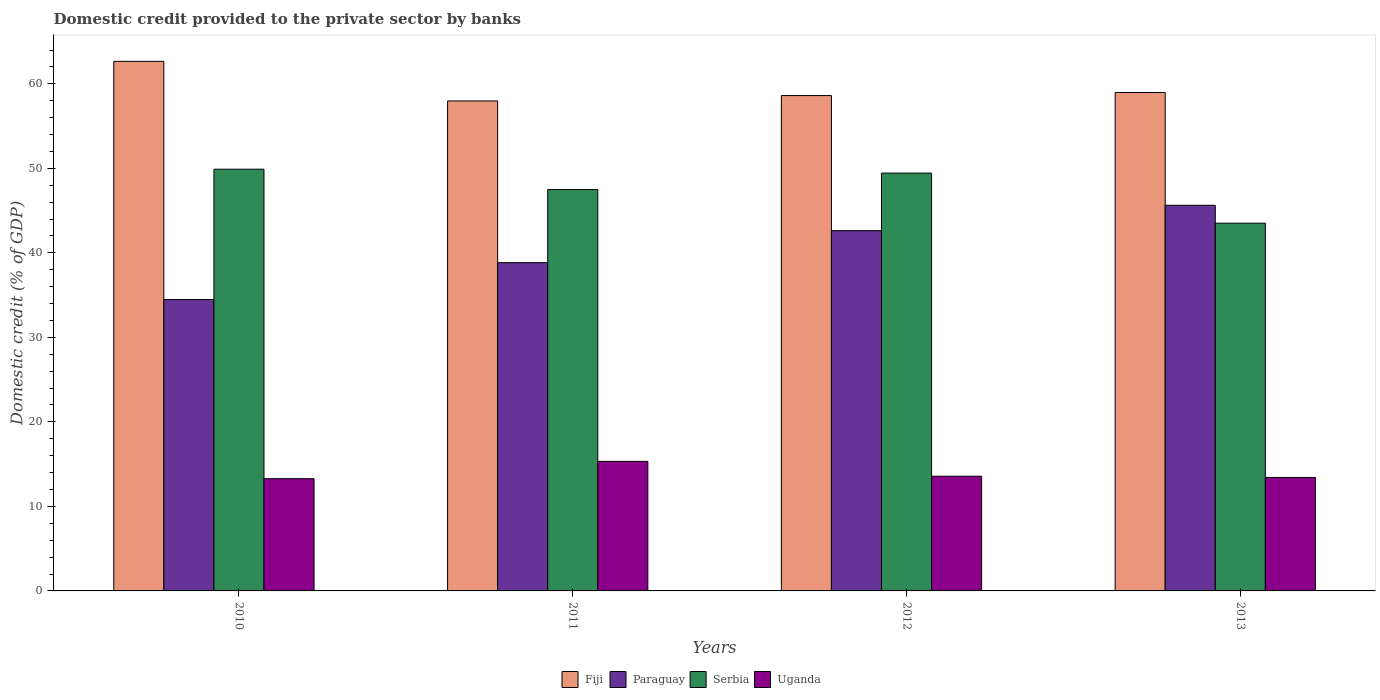How many groups of bars are there?
Your answer should be compact. 4. Are the number of bars per tick equal to the number of legend labels?
Ensure brevity in your answer.  Yes. Are the number of bars on each tick of the X-axis equal?
Give a very brief answer. Yes. How many bars are there on the 4th tick from the left?
Ensure brevity in your answer.  4. How many bars are there on the 2nd tick from the right?
Offer a terse response. 4. What is the domestic credit provided to the private sector by banks in Uganda in 2012?
Ensure brevity in your answer.  13.57. Across all years, what is the maximum domestic credit provided to the private sector by banks in Serbia?
Offer a very short reply. 49.9. Across all years, what is the minimum domestic credit provided to the private sector by banks in Fiji?
Give a very brief answer. 57.97. In which year was the domestic credit provided to the private sector by banks in Fiji maximum?
Keep it short and to the point. 2010. What is the total domestic credit provided to the private sector by banks in Uganda in the graph?
Provide a succinct answer. 55.61. What is the difference between the domestic credit provided to the private sector by banks in Uganda in 2010 and that in 2013?
Keep it short and to the point. -0.15. What is the difference between the domestic credit provided to the private sector by banks in Fiji in 2012 and the domestic credit provided to the private sector by banks in Paraguay in 2013?
Your answer should be very brief. 12.98. What is the average domestic credit provided to the private sector by banks in Fiji per year?
Offer a very short reply. 59.55. In the year 2013, what is the difference between the domestic credit provided to the private sector by banks in Serbia and domestic credit provided to the private sector by banks in Uganda?
Keep it short and to the point. 30.08. What is the ratio of the domestic credit provided to the private sector by banks in Uganda in 2012 to that in 2013?
Your answer should be compact. 1.01. Is the domestic credit provided to the private sector by banks in Paraguay in 2011 less than that in 2013?
Offer a very short reply. Yes. What is the difference between the highest and the second highest domestic credit provided to the private sector by banks in Uganda?
Give a very brief answer. 1.75. What is the difference between the highest and the lowest domestic credit provided to the private sector by banks in Serbia?
Keep it short and to the point. 6.39. In how many years, is the domestic credit provided to the private sector by banks in Uganda greater than the average domestic credit provided to the private sector by banks in Uganda taken over all years?
Provide a succinct answer. 1. Is the sum of the domestic credit provided to the private sector by banks in Paraguay in 2010 and 2012 greater than the maximum domestic credit provided to the private sector by banks in Serbia across all years?
Give a very brief answer. Yes. What does the 1st bar from the left in 2010 represents?
Make the answer very short. Fiji. What does the 1st bar from the right in 2013 represents?
Provide a succinct answer. Uganda. Is it the case that in every year, the sum of the domestic credit provided to the private sector by banks in Fiji and domestic credit provided to the private sector by banks in Serbia is greater than the domestic credit provided to the private sector by banks in Uganda?
Your answer should be compact. Yes. How many years are there in the graph?
Offer a very short reply. 4. Are the values on the major ticks of Y-axis written in scientific E-notation?
Offer a very short reply. No. Does the graph contain any zero values?
Offer a very short reply. No. Does the graph contain grids?
Provide a short and direct response. No. Where does the legend appear in the graph?
Keep it short and to the point. Bottom center. How many legend labels are there?
Your answer should be very brief. 4. What is the title of the graph?
Keep it short and to the point. Domestic credit provided to the private sector by banks. What is the label or title of the Y-axis?
Your response must be concise. Domestic credit (% of GDP). What is the Domestic credit (% of GDP) of Fiji in 2010?
Provide a succinct answer. 62.66. What is the Domestic credit (% of GDP) of Paraguay in 2010?
Give a very brief answer. 34.48. What is the Domestic credit (% of GDP) of Serbia in 2010?
Give a very brief answer. 49.9. What is the Domestic credit (% of GDP) in Uganda in 2010?
Provide a short and direct response. 13.28. What is the Domestic credit (% of GDP) of Fiji in 2011?
Provide a succinct answer. 57.97. What is the Domestic credit (% of GDP) in Paraguay in 2011?
Offer a terse response. 38.84. What is the Domestic credit (% of GDP) of Serbia in 2011?
Your response must be concise. 47.49. What is the Domestic credit (% of GDP) in Uganda in 2011?
Keep it short and to the point. 15.33. What is the Domestic credit (% of GDP) in Fiji in 2012?
Your answer should be compact. 58.61. What is the Domestic credit (% of GDP) of Paraguay in 2012?
Offer a very short reply. 42.62. What is the Domestic credit (% of GDP) in Serbia in 2012?
Offer a terse response. 49.44. What is the Domestic credit (% of GDP) in Uganda in 2012?
Make the answer very short. 13.57. What is the Domestic credit (% of GDP) in Fiji in 2013?
Offer a very short reply. 58.97. What is the Domestic credit (% of GDP) of Paraguay in 2013?
Ensure brevity in your answer.  45.63. What is the Domestic credit (% of GDP) of Serbia in 2013?
Provide a succinct answer. 43.51. What is the Domestic credit (% of GDP) of Uganda in 2013?
Give a very brief answer. 13.43. Across all years, what is the maximum Domestic credit (% of GDP) in Fiji?
Your response must be concise. 62.66. Across all years, what is the maximum Domestic credit (% of GDP) in Paraguay?
Make the answer very short. 45.63. Across all years, what is the maximum Domestic credit (% of GDP) of Serbia?
Give a very brief answer. 49.9. Across all years, what is the maximum Domestic credit (% of GDP) of Uganda?
Provide a short and direct response. 15.33. Across all years, what is the minimum Domestic credit (% of GDP) in Fiji?
Make the answer very short. 57.97. Across all years, what is the minimum Domestic credit (% of GDP) in Paraguay?
Your response must be concise. 34.48. Across all years, what is the minimum Domestic credit (% of GDP) of Serbia?
Ensure brevity in your answer.  43.51. Across all years, what is the minimum Domestic credit (% of GDP) of Uganda?
Your answer should be compact. 13.28. What is the total Domestic credit (% of GDP) in Fiji in the graph?
Make the answer very short. 238.22. What is the total Domestic credit (% of GDP) of Paraguay in the graph?
Your answer should be compact. 161.57. What is the total Domestic credit (% of GDP) in Serbia in the graph?
Ensure brevity in your answer.  190.33. What is the total Domestic credit (% of GDP) of Uganda in the graph?
Your answer should be very brief. 55.61. What is the difference between the Domestic credit (% of GDP) in Fiji in 2010 and that in 2011?
Provide a succinct answer. 4.68. What is the difference between the Domestic credit (% of GDP) of Paraguay in 2010 and that in 2011?
Keep it short and to the point. -4.36. What is the difference between the Domestic credit (% of GDP) of Serbia in 2010 and that in 2011?
Keep it short and to the point. 2.41. What is the difference between the Domestic credit (% of GDP) in Uganda in 2010 and that in 2011?
Provide a short and direct response. -2.05. What is the difference between the Domestic credit (% of GDP) of Fiji in 2010 and that in 2012?
Your response must be concise. 4.05. What is the difference between the Domestic credit (% of GDP) in Paraguay in 2010 and that in 2012?
Make the answer very short. -8.14. What is the difference between the Domestic credit (% of GDP) of Serbia in 2010 and that in 2012?
Make the answer very short. 0.46. What is the difference between the Domestic credit (% of GDP) in Uganda in 2010 and that in 2012?
Your response must be concise. -0.29. What is the difference between the Domestic credit (% of GDP) in Fiji in 2010 and that in 2013?
Keep it short and to the point. 3.68. What is the difference between the Domestic credit (% of GDP) in Paraguay in 2010 and that in 2013?
Ensure brevity in your answer.  -11.15. What is the difference between the Domestic credit (% of GDP) of Serbia in 2010 and that in 2013?
Keep it short and to the point. 6.39. What is the difference between the Domestic credit (% of GDP) of Uganda in 2010 and that in 2013?
Your answer should be compact. -0.15. What is the difference between the Domestic credit (% of GDP) in Fiji in 2011 and that in 2012?
Your response must be concise. -0.64. What is the difference between the Domestic credit (% of GDP) of Paraguay in 2011 and that in 2012?
Make the answer very short. -3.79. What is the difference between the Domestic credit (% of GDP) of Serbia in 2011 and that in 2012?
Offer a very short reply. -1.95. What is the difference between the Domestic credit (% of GDP) of Uganda in 2011 and that in 2012?
Your answer should be very brief. 1.75. What is the difference between the Domestic credit (% of GDP) in Fiji in 2011 and that in 2013?
Offer a terse response. -1. What is the difference between the Domestic credit (% of GDP) of Paraguay in 2011 and that in 2013?
Offer a very short reply. -6.79. What is the difference between the Domestic credit (% of GDP) in Serbia in 2011 and that in 2013?
Make the answer very short. 3.98. What is the difference between the Domestic credit (% of GDP) of Uganda in 2011 and that in 2013?
Your answer should be very brief. 1.9. What is the difference between the Domestic credit (% of GDP) in Fiji in 2012 and that in 2013?
Keep it short and to the point. -0.36. What is the difference between the Domestic credit (% of GDP) in Paraguay in 2012 and that in 2013?
Make the answer very short. -3.01. What is the difference between the Domestic credit (% of GDP) of Serbia in 2012 and that in 2013?
Provide a short and direct response. 5.92. What is the difference between the Domestic credit (% of GDP) in Uganda in 2012 and that in 2013?
Make the answer very short. 0.15. What is the difference between the Domestic credit (% of GDP) of Fiji in 2010 and the Domestic credit (% of GDP) of Paraguay in 2011?
Your answer should be very brief. 23.82. What is the difference between the Domestic credit (% of GDP) in Fiji in 2010 and the Domestic credit (% of GDP) in Serbia in 2011?
Make the answer very short. 15.17. What is the difference between the Domestic credit (% of GDP) of Fiji in 2010 and the Domestic credit (% of GDP) of Uganda in 2011?
Make the answer very short. 47.33. What is the difference between the Domestic credit (% of GDP) of Paraguay in 2010 and the Domestic credit (% of GDP) of Serbia in 2011?
Ensure brevity in your answer.  -13.01. What is the difference between the Domestic credit (% of GDP) in Paraguay in 2010 and the Domestic credit (% of GDP) in Uganda in 2011?
Ensure brevity in your answer.  19.15. What is the difference between the Domestic credit (% of GDP) in Serbia in 2010 and the Domestic credit (% of GDP) in Uganda in 2011?
Provide a short and direct response. 34.57. What is the difference between the Domestic credit (% of GDP) of Fiji in 2010 and the Domestic credit (% of GDP) of Paraguay in 2012?
Ensure brevity in your answer.  20.03. What is the difference between the Domestic credit (% of GDP) in Fiji in 2010 and the Domestic credit (% of GDP) in Serbia in 2012?
Your answer should be compact. 13.22. What is the difference between the Domestic credit (% of GDP) of Fiji in 2010 and the Domestic credit (% of GDP) of Uganda in 2012?
Offer a terse response. 49.09. What is the difference between the Domestic credit (% of GDP) in Paraguay in 2010 and the Domestic credit (% of GDP) in Serbia in 2012?
Provide a succinct answer. -14.96. What is the difference between the Domestic credit (% of GDP) in Paraguay in 2010 and the Domestic credit (% of GDP) in Uganda in 2012?
Ensure brevity in your answer.  20.91. What is the difference between the Domestic credit (% of GDP) of Serbia in 2010 and the Domestic credit (% of GDP) of Uganda in 2012?
Offer a terse response. 36.32. What is the difference between the Domestic credit (% of GDP) of Fiji in 2010 and the Domestic credit (% of GDP) of Paraguay in 2013?
Provide a succinct answer. 17.03. What is the difference between the Domestic credit (% of GDP) of Fiji in 2010 and the Domestic credit (% of GDP) of Serbia in 2013?
Offer a very short reply. 19.15. What is the difference between the Domestic credit (% of GDP) in Fiji in 2010 and the Domestic credit (% of GDP) in Uganda in 2013?
Provide a short and direct response. 49.23. What is the difference between the Domestic credit (% of GDP) of Paraguay in 2010 and the Domestic credit (% of GDP) of Serbia in 2013?
Keep it short and to the point. -9.03. What is the difference between the Domestic credit (% of GDP) of Paraguay in 2010 and the Domestic credit (% of GDP) of Uganda in 2013?
Keep it short and to the point. 21.05. What is the difference between the Domestic credit (% of GDP) of Serbia in 2010 and the Domestic credit (% of GDP) of Uganda in 2013?
Ensure brevity in your answer.  36.47. What is the difference between the Domestic credit (% of GDP) of Fiji in 2011 and the Domestic credit (% of GDP) of Paraguay in 2012?
Your answer should be very brief. 15.35. What is the difference between the Domestic credit (% of GDP) in Fiji in 2011 and the Domestic credit (% of GDP) in Serbia in 2012?
Give a very brief answer. 8.54. What is the difference between the Domestic credit (% of GDP) of Fiji in 2011 and the Domestic credit (% of GDP) of Uganda in 2012?
Make the answer very short. 44.4. What is the difference between the Domestic credit (% of GDP) of Paraguay in 2011 and the Domestic credit (% of GDP) of Serbia in 2012?
Your answer should be very brief. -10.6. What is the difference between the Domestic credit (% of GDP) in Paraguay in 2011 and the Domestic credit (% of GDP) in Uganda in 2012?
Provide a short and direct response. 25.26. What is the difference between the Domestic credit (% of GDP) of Serbia in 2011 and the Domestic credit (% of GDP) of Uganda in 2012?
Ensure brevity in your answer.  33.92. What is the difference between the Domestic credit (% of GDP) of Fiji in 2011 and the Domestic credit (% of GDP) of Paraguay in 2013?
Provide a succinct answer. 12.34. What is the difference between the Domestic credit (% of GDP) of Fiji in 2011 and the Domestic credit (% of GDP) of Serbia in 2013?
Your answer should be very brief. 14.46. What is the difference between the Domestic credit (% of GDP) in Fiji in 2011 and the Domestic credit (% of GDP) in Uganda in 2013?
Give a very brief answer. 44.55. What is the difference between the Domestic credit (% of GDP) of Paraguay in 2011 and the Domestic credit (% of GDP) of Serbia in 2013?
Provide a succinct answer. -4.67. What is the difference between the Domestic credit (% of GDP) in Paraguay in 2011 and the Domestic credit (% of GDP) in Uganda in 2013?
Ensure brevity in your answer.  25.41. What is the difference between the Domestic credit (% of GDP) of Serbia in 2011 and the Domestic credit (% of GDP) of Uganda in 2013?
Make the answer very short. 34.06. What is the difference between the Domestic credit (% of GDP) of Fiji in 2012 and the Domestic credit (% of GDP) of Paraguay in 2013?
Offer a very short reply. 12.98. What is the difference between the Domestic credit (% of GDP) in Fiji in 2012 and the Domestic credit (% of GDP) in Serbia in 2013?
Give a very brief answer. 15.1. What is the difference between the Domestic credit (% of GDP) in Fiji in 2012 and the Domestic credit (% of GDP) in Uganda in 2013?
Give a very brief answer. 45.18. What is the difference between the Domestic credit (% of GDP) of Paraguay in 2012 and the Domestic credit (% of GDP) of Serbia in 2013?
Offer a very short reply. -0.89. What is the difference between the Domestic credit (% of GDP) in Paraguay in 2012 and the Domestic credit (% of GDP) in Uganda in 2013?
Your answer should be compact. 29.2. What is the difference between the Domestic credit (% of GDP) of Serbia in 2012 and the Domestic credit (% of GDP) of Uganda in 2013?
Your answer should be very brief. 36.01. What is the average Domestic credit (% of GDP) of Fiji per year?
Ensure brevity in your answer.  59.55. What is the average Domestic credit (% of GDP) in Paraguay per year?
Keep it short and to the point. 40.39. What is the average Domestic credit (% of GDP) in Serbia per year?
Make the answer very short. 47.58. What is the average Domestic credit (% of GDP) of Uganda per year?
Provide a succinct answer. 13.9. In the year 2010, what is the difference between the Domestic credit (% of GDP) of Fiji and Domestic credit (% of GDP) of Paraguay?
Your answer should be compact. 28.18. In the year 2010, what is the difference between the Domestic credit (% of GDP) in Fiji and Domestic credit (% of GDP) in Serbia?
Offer a very short reply. 12.76. In the year 2010, what is the difference between the Domestic credit (% of GDP) of Fiji and Domestic credit (% of GDP) of Uganda?
Provide a succinct answer. 49.38. In the year 2010, what is the difference between the Domestic credit (% of GDP) of Paraguay and Domestic credit (% of GDP) of Serbia?
Give a very brief answer. -15.42. In the year 2010, what is the difference between the Domestic credit (% of GDP) of Paraguay and Domestic credit (% of GDP) of Uganda?
Offer a very short reply. 21.2. In the year 2010, what is the difference between the Domestic credit (% of GDP) of Serbia and Domestic credit (% of GDP) of Uganda?
Your answer should be very brief. 36.62. In the year 2011, what is the difference between the Domestic credit (% of GDP) of Fiji and Domestic credit (% of GDP) of Paraguay?
Your answer should be very brief. 19.14. In the year 2011, what is the difference between the Domestic credit (% of GDP) in Fiji and Domestic credit (% of GDP) in Serbia?
Offer a terse response. 10.48. In the year 2011, what is the difference between the Domestic credit (% of GDP) in Fiji and Domestic credit (% of GDP) in Uganda?
Your answer should be very brief. 42.65. In the year 2011, what is the difference between the Domestic credit (% of GDP) of Paraguay and Domestic credit (% of GDP) of Serbia?
Offer a terse response. -8.65. In the year 2011, what is the difference between the Domestic credit (% of GDP) of Paraguay and Domestic credit (% of GDP) of Uganda?
Your answer should be very brief. 23.51. In the year 2011, what is the difference between the Domestic credit (% of GDP) of Serbia and Domestic credit (% of GDP) of Uganda?
Your response must be concise. 32.16. In the year 2012, what is the difference between the Domestic credit (% of GDP) of Fiji and Domestic credit (% of GDP) of Paraguay?
Provide a short and direct response. 15.99. In the year 2012, what is the difference between the Domestic credit (% of GDP) of Fiji and Domestic credit (% of GDP) of Serbia?
Provide a succinct answer. 9.17. In the year 2012, what is the difference between the Domestic credit (% of GDP) of Fiji and Domestic credit (% of GDP) of Uganda?
Your response must be concise. 45.04. In the year 2012, what is the difference between the Domestic credit (% of GDP) in Paraguay and Domestic credit (% of GDP) in Serbia?
Your response must be concise. -6.81. In the year 2012, what is the difference between the Domestic credit (% of GDP) of Paraguay and Domestic credit (% of GDP) of Uganda?
Your response must be concise. 29.05. In the year 2012, what is the difference between the Domestic credit (% of GDP) in Serbia and Domestic credit (% of GDP) in Uganda?
Offer a very short reply. 35.86. In the year 2013, what is the difference between the Domestic credit (% of GDP) in Fiji and Domestic credit (% of GDP) in Paraguay?
Your answer should be very brief. 13.34. In the year 2013, what is the difference between the Domestic credit (% of GDP) in Fiji and Domestic credit (% of GDP) in Serbia?
Your answer should be compact. 15.46. In the year 2013, what is the difference between the Domestic credit (% of GDP) of Fiji and Domestic credit (% of GDP) of Uganda?
Keep it short and to the point. 45.55. In the year 2013, what is the difference between the Domestic credit (% of GDP) of Paraguay and Domestic credit (% of GDP) of Serbia?
Offer a terse response. 2.12. In the year 2013, what is the difference between the Domestic credit (% of GDP) in Paraguay and Domestic credit (% of GDP) in Uganda?
Your response must be concise. 32.2. In the year 2013, what is the difference between the Domestic credit (% of GDP) of Serbia and Domestic credit (% of GDP) of Uganda?
Make the answer very short. 30.08. What is the ratio of the Domestic credit (% of GDP) in Fiji in 2010 to that in 2011?
Provide a short and direct response. 1.08. What is the ratio of the Domestic credit (% of GDP) in Paraguay in 2010 to that in 2011?
Give a very brief answer. 0.89. What is the ratio of the Domestic credit (% of GDP) of Serbia in 2010 to that in 2011?
Provide a short and direct response. 1.05. What is the ratio of the Domestic credit (% of GDP) of Uganda in 2010 to that in 2011?
Provide a short and direct response. 0.87. What is the ratio of the Domestic credit (% of GDP) of Fiji in 2010 to that in 2012?
Offer a very short reply. 1.07. What is the ratio of the Domestic credit (% of GDP) in Paraguay in 2010 to that in 2012?
Your response must be concise. 0.81. What is the ratio of the Domestic credit (% of GDP) of Serbia in 2010 to that in 2012?
Offer a very short reply. 1.01. What is the ratio of the Domestic credit (% of GDP) in Uganda in 2010 to that in 2012?
Your answer should be compact. 0.98. What is the ratio of the Domestic credit (% of GDP) of Paraguay in 2010 to that in 2013?
Keep it short and to the point. 0.76. What is the ratio of the Domestic credit (% of GDP) of Serbia in 2010 to that in 2013?
Ensure brevity in your answer.  1.15. What is the ratio of the Domestic credit (% of GDP) in Uganda in 2010 to that in 2013?
Offer a very short reply. 0.99. What is the ratio of the Domestic credit (% of GDP) in Fiji in 2011 to that in 2012?
Offer a terse response. 0.99. What is the ratio of the Domestic credit (% of GDP) of Paraguay in 2011 to that in 2012?
Provide a short and direct response. 0.91. What is the ratio of the Domestic credit (% of GDP) in Serbia in 2011 to that in 2012?
Your answer should be very brief. 0.96. What is the ratio of the Domestic credit (% of GDP) in Uganda in 2011 to that in 2012?
Give a very brief answer. 1.13. What is the ratio of the Domestic credit (% of GDP) in Fiji in 2011 to that in 2013?
Give a very brief answer. 0.98. What is the ratio of the Domestic credit (% of GDP) of Paraguay in 2011 to that in 2013?
Give a very brief answer. 0.85. What is the ratio of the Domestic credit (% of GDP) of Serbia in 2011 to that in 2013?
Keep it short and to the point. 1.09. What is the ratio of the Domestic credit (% of GDP) of Uganda in 2011 to that in 2013?
Offer a terse response. 1.14. What is the ratio of the Domestic credit (% of GDP) of Fiji in 2012 to that in 2013?
Make the answer very short. 0.99. What is the ratio of the Domestic credit (% of GDP) in Paraguay in 2012 to that in 2013?
Your answer should be compact. 0.93. What is the ratio of the Domestic credit (% of GDP) of Serbia in 2012 to that in 2013?
Provide a succinct answer. 1.14. What is the ratio of the Domestic credit (% of GDP) of Uganda in 2012 to that in 2013?
Offer a terse response. 1.01. What is the difference between the highest and the second highest Domestic credit (% of GDP) in Fiji?
Make the answer very short. 3.68. What is the difference between the highest and the second highest Domestic credit (% of GDP) in Paraguay?
Your answer should be compact. 3.01. What is the difference between the highest and the second highest Domestic credit (% of GDP) of Serbia?
Provide a succinct answer. 0.46. What is the difference between the highest and the second highest Domestic credit (% of GDP) of Uganda?
Offer a terse response. 1.75. What is the difference between the highest and the lowest Domestic credit (% of GDP) in Fiji?
Your answer should be very brief. 4.68. What is the difference between the highest and the lowest Domestic credit (% of GDP) of Paraguay?
Your response must be concise. 11.15. What is the difference between the highest and the lowest Domestic credit (% of GDP) of Serbia?
Make the answer very short. 6.39. What is the difference between the highest and the lowest Domestic credit (% of GDP) of Uganda?
Ensure brevity in your answer.  2.05. 